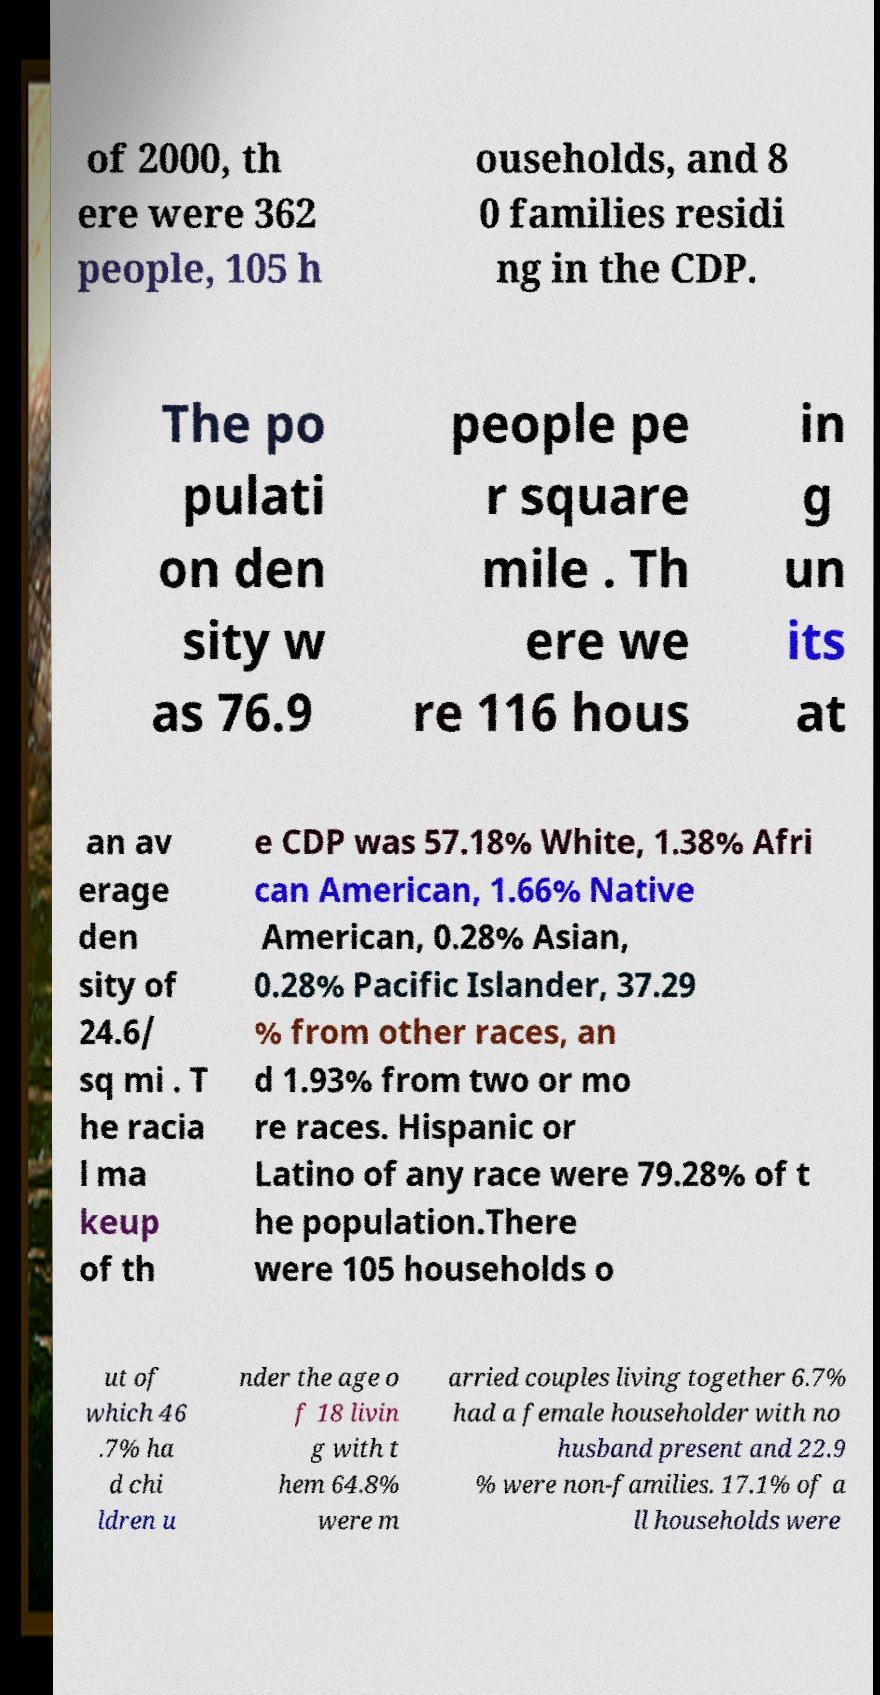Can you accurately transcribe the text from the provided image for me? of 2000, th ere were 362 people, 105 h ouseholds, and 8 0 families residi ng in the CDP. The po pulati on den sity w as 76.9 people pe r square mile . Th ere we re 116 hous in g un its at an av erage den sity of 24.6/ sq mi . T he racia l ma keup of th e CDP was 57.18% White, 1.38% Afri can American, 1.66% Native American, 0.28% Asian, 0.28% Pacific Islander, 37.29 % from other races, an d 1.93% from two or mo re races. Hispanic or Latino of any race were 79.28% of t he population.There were 105 households o ut of which 46 .7% ha d chi ldren u nder the age o f 18 livin g with t hem 64.8% were m arried couples living together 6.7% had a female householder with no husband present and 22.9 % were non-families. 17.1% of a ll households were 